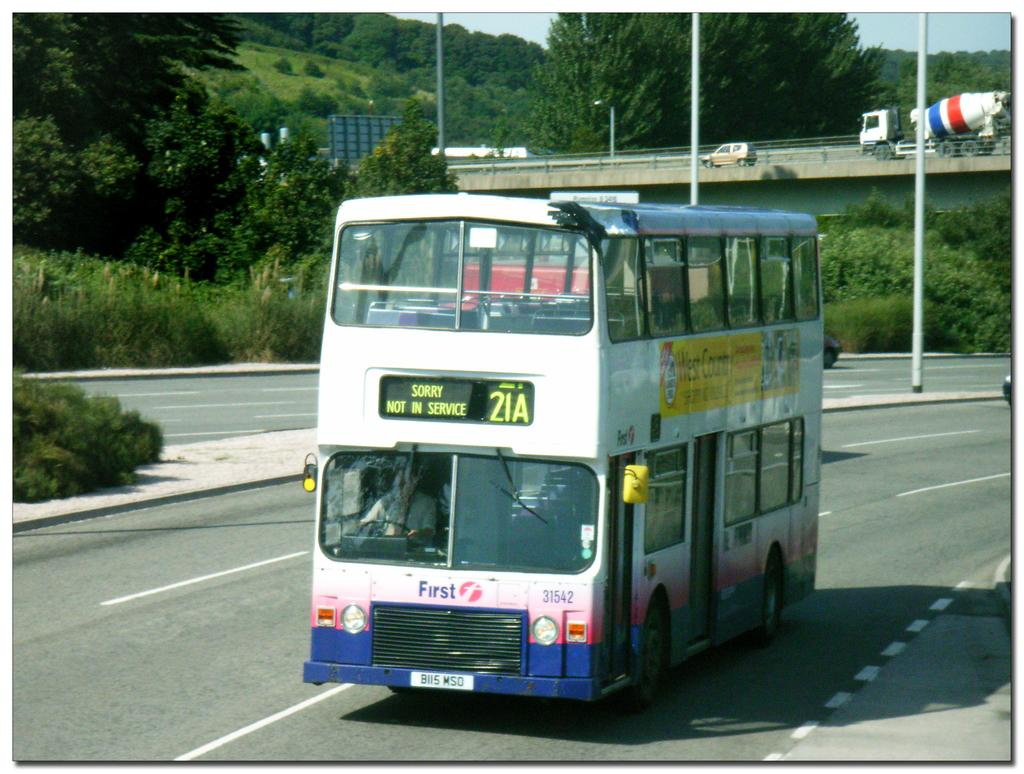Provide a one-sentence caption for the provided image. Double decker bus on the road that is not in service. 